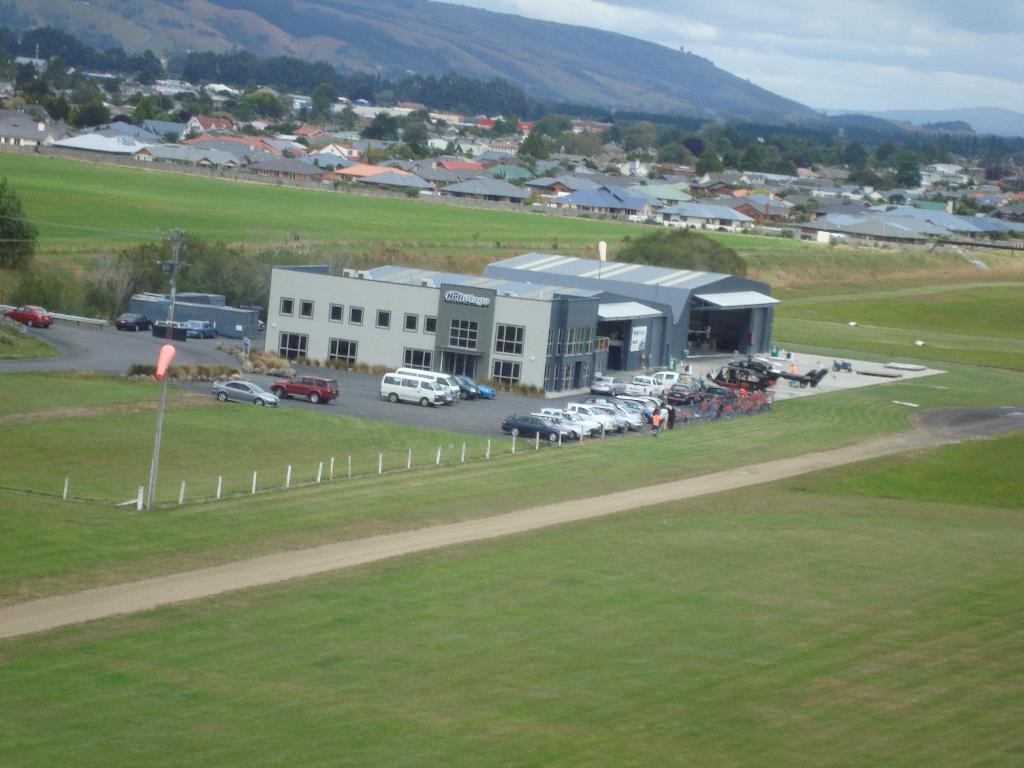Could you give a brief overview of what you see in this image? As we can see in the image there is grass, fence, cars, buildings, trees, houses, hills and sky. 